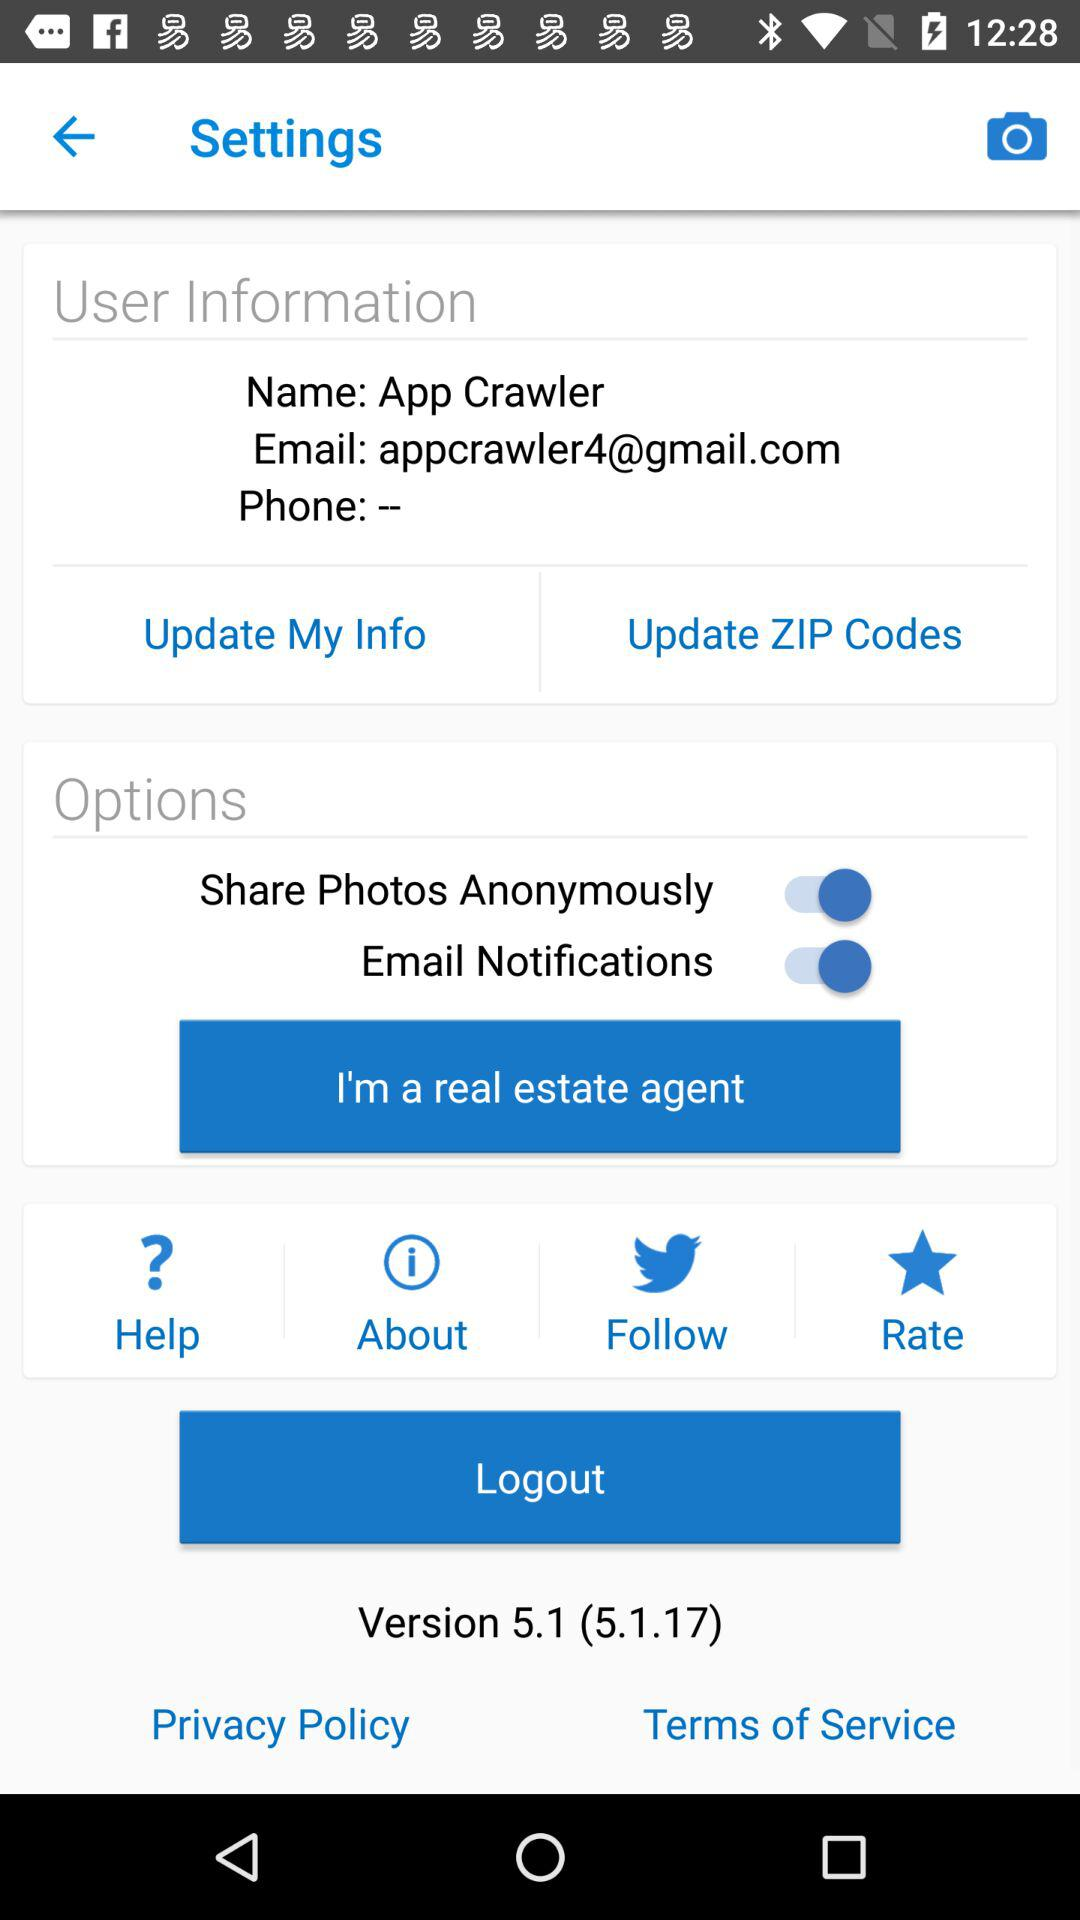What is the name of the user? The name of the user is App Crawler. 